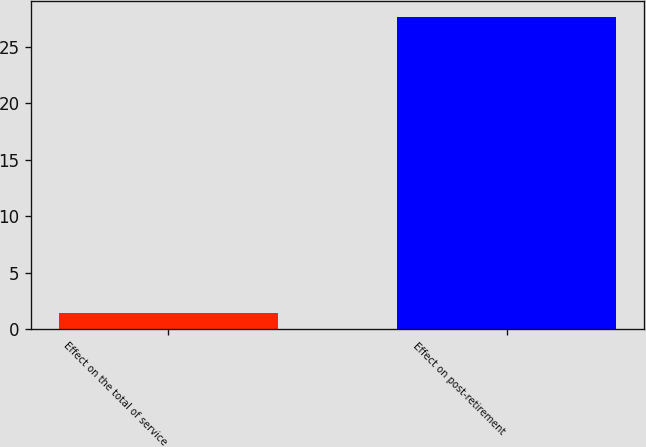<chart> <loc_0><loc_0><loc_500><loc_500><bar_chart><fcel>Effect on the total of service<fcel>Effect on post-retirement<nl><fcel>1.4<fcel>27.7<nl></chart> 